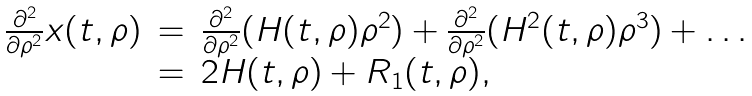<formula> <loc_0><loc_0><loc_500><loc_500>\begin{array} { r c l } \frac { \partial ^ { 2 } } { \partial \rho ^ { 2 } } x ( t , \rho ) & = & \frac { \partial ^ { 2 } } { \partial \rho ^ { 2 } } ( H ( t , \rho ) \rho ^ { 2 } ) + \frac { \partial ^ { 2 } } { \partial \rho ^ { 2 } } ( H ^ { 2 } ( t , \rho ) \rho ^ { 3 } ) + \dots \\ & = & 2 H ( t , \rho ) + R _ { 1 } ( t , \rho ) , \end{array}</formula> 